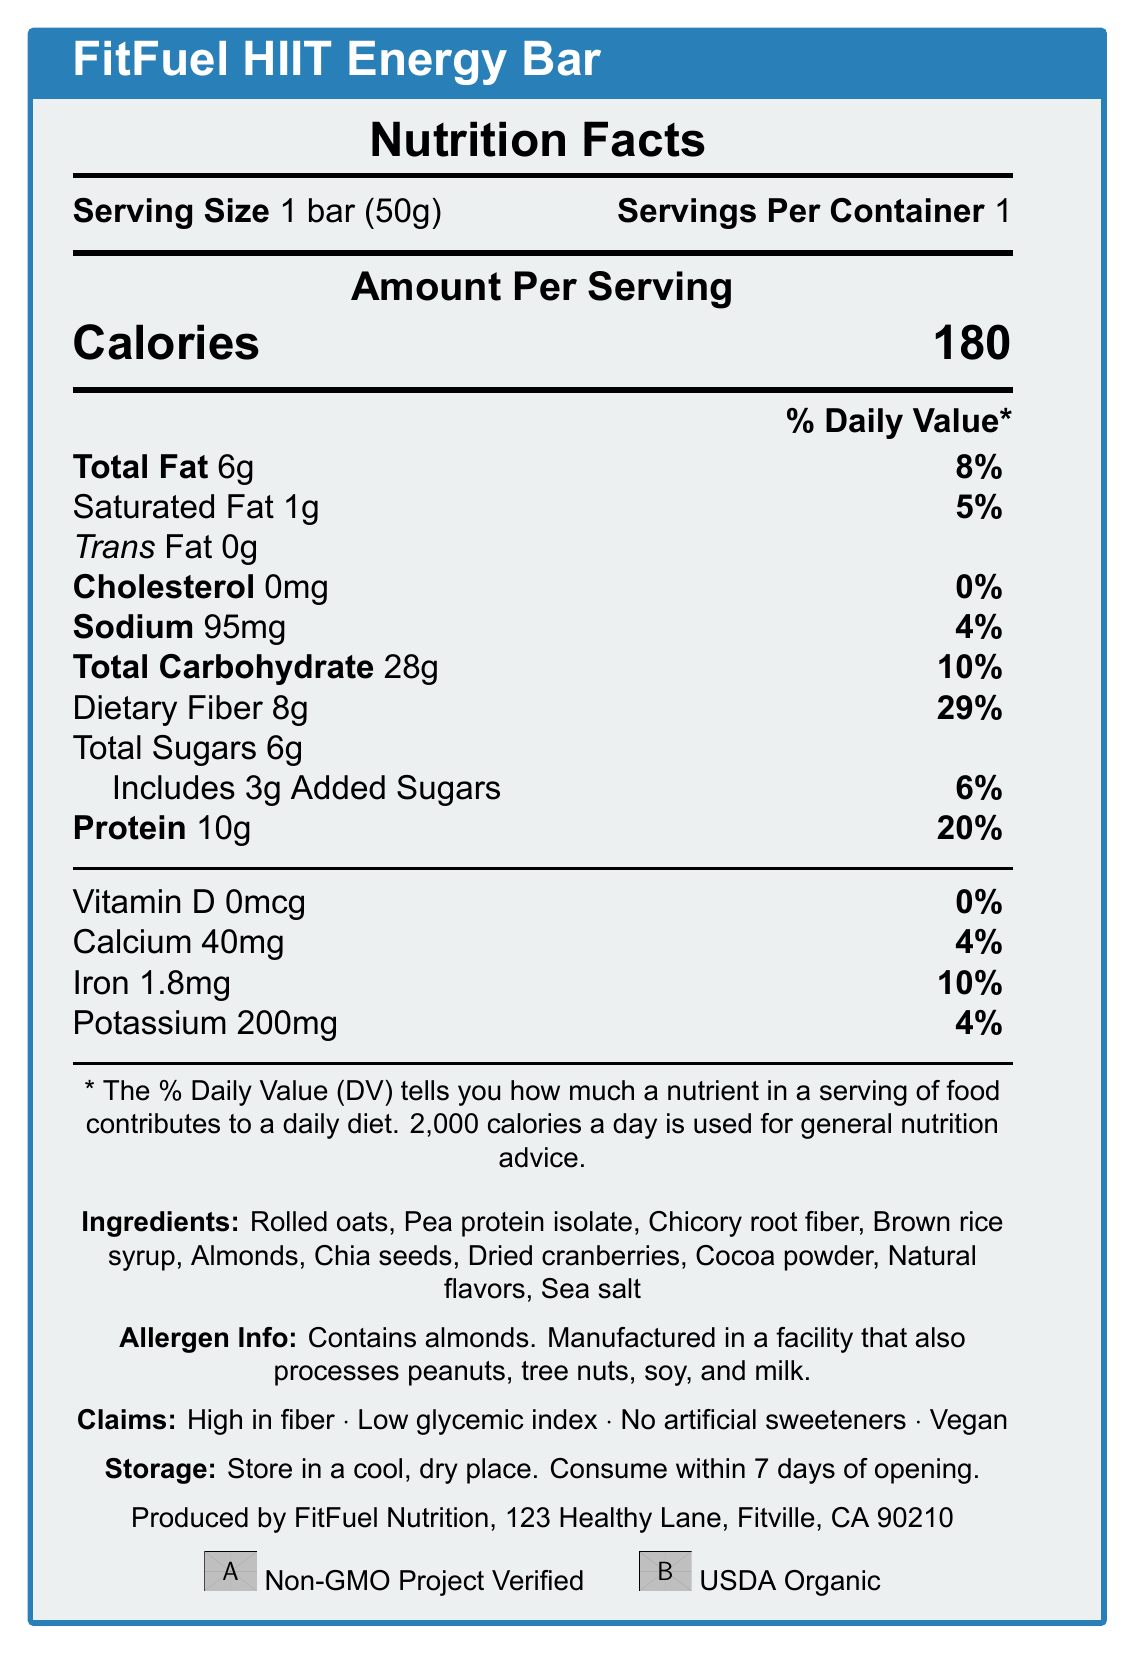What is the serving size of the FitFuel HIIT Energy Bar? The serving size is stated as 1 bar (50g) in the document.
Answer: 1 bar (50g) How many calories are in one serving of the energy bar? The document states that the amount per serving is 180 calories.
Answer: 180 calories What is the amount of dietary fiber in one serving, and what percentage of the daily value does it represent? One serving contains 8g of dietary fiber, which represents 29% of the daily value.
Answer: 8g, 29% Which ingredient is listed first in the ingredients list? The first ingredient listed is "Rolled oats," indicating it is the most predominant ingredient by weight.
Answer: Rolled oats What are the allergens mentioned in the document? The allergen information states that the product contains almonds.
Answer: Almonds What nutrients have a 0% daily value in the FitFuel HIIT Energy Bar? A. Vitamin D B. Saturated Fat C. Cholesterol D. Iron Vitamin D and Cholesterol have a 0% Daily Value, as indicated in the document.
Answer: A and C Which of the following claims is NOT made about the FitFuel HIIT Energy Bar? i. High in fiber ii. Low glycemic index iii. Gluten-free iv. Vegan The claims mentioned in the document are high in fiber, low glycemic index, and vegan. Gluten-free is not listed.
Answer: iii. Gluten-free Does the energy bar contain any artificial sweeteners? The claim section explicitly states "No artificial sweeteners."
Answer: No Can the product be stored at room temperature, and how long should it be consumed after opening? The storage instructions indicate that the bar should be stored in a cool, dry place and consumed within 7 days of opening.
Answer: Yes, within 7 days Summarize the main nutritional benefits and claims of the FitFuel HIIT Energy Bar. The document highlights the bar's nutritional content, including calories, protein, dietary fiber, and its absence of artificial sweeteners. It also emphasizes the product's health claims and certifications.
Answer: The FitFuel HIIT Energy Bar is a high-fiber, low-calorie energy bar with 180 calories per serving. It contains 10g of protein, 8g of dietary fiber, and low sodium levels. The bar is vegan, high in fiber, has a low glycemic index, and contains no artificial sweeteners. The ingredients are natural and it is non-GMO and USDA organic certified. What is the calcium content per serving of the energy bar? The document lists the calcium content as 40mg per serving, accounting for 4% of the daily value.
Answer: 40mg How much added sugar does the FitFuel HIIT Energy Bar contain, and what is the percentage daily value? The energy bar includes 3g of added sugars, representing 6% of the daily value.
Answer: 3g, 6% What is the potassium content in one serving of the bar? The potassium content per serving is listed as 200mg, which is 4% of the daily value.
Answer: 200mg Is the FitFuel HIIT Energy Bar gluten-free? The document does not provide any information regarding the gluten content of the energy bar.
Answer: Cannot be determined 